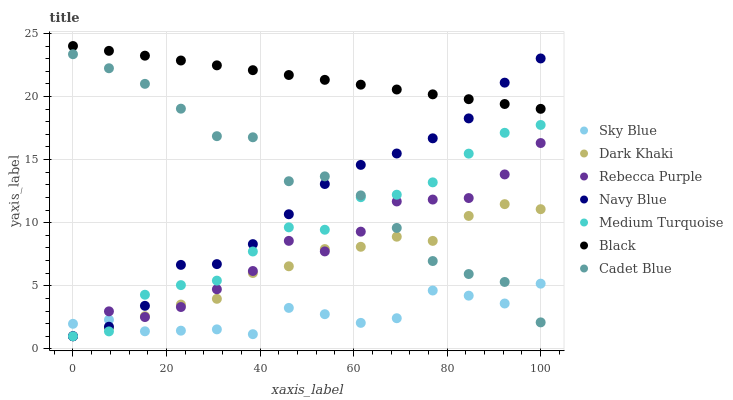Does Sky Blue have the minimum area under the curve?
Answer yes or no. Yes. Does Black have the maximum area under the curve?
Answer yes or no. Yes. Does Navy Blue have the minimum area under the curve?
Answer yes or no. No. Does Navy Blue have the maximum area under the curve?
Answer yes or no. No. Is Black the smoothest?
Answer yes or no. Yes. Is Medium Turquoise the roughest?
Answer yes or no. Yes. Is Navy Blue the smoothest?
Answer yes or no. No. Is Navy Blue the roughest?
Answer yes or no. No. Does Navy Blue have the lowest value?
Answer yes or no. Yes. Does Black have the lowest value?
Answer yes or no. No. Does Black have the highest value?
Answer yes or no. Yes. Does Navy Blue have the highest value?
Answer yes or no. No. Is Rebecca Purple less than Black?
Answer yes or no. Yes. Is Black greater than Dark Khaki?
Answer yes or no. Yes. Does Rebecca Purple intersect Medium Turquoise?
Answer yes or no. Yes. Is Rebecca Purple less than Medium Turquoise?
Answer yes or no. No. Is Rebecca Purple greater than Medium Turquoise?
Answer yes or no. No. Does Rebecca Purple intersect Black?
Answer yes or no. No. 